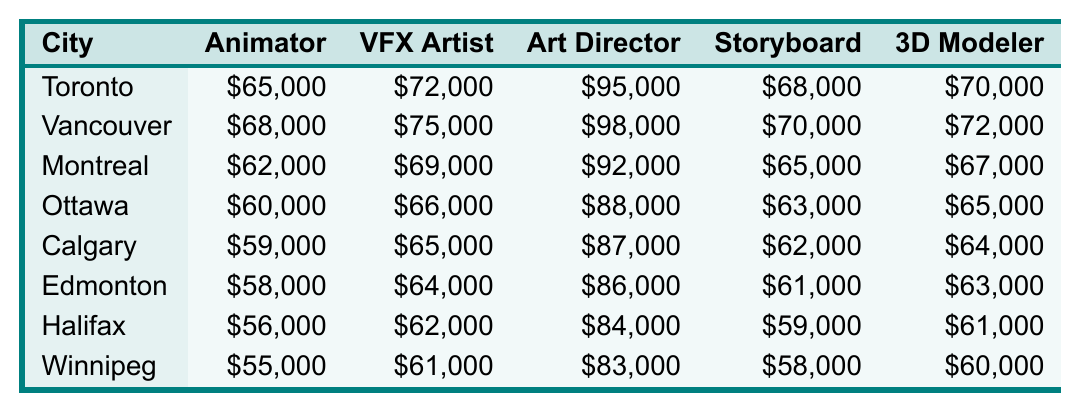What is the highest salary for an Art Director in the listed cities? The highest salary for an Art Director is in Vancouver, where it is $98,000.
Answer: $98,000 Which city offers the lowest salary for a 3D Modeler? In Winnipeg, the salary for a 3D Modeler is the lowest at $60,000.
Answer: $60,000 What is the average salary for an Animator across all the cities? Adding the salaries for Animators: 65000 + 68000 + 62000 + 60000 + 59000 + 58000 + 56000 + 55000 = 4,840,000. There are 8 cities, so the average is 4840000/8 = 60500.
Answer: $60,500 Is the salary for a Visual Effects Artist in Calgary higher than that in Ottawa? The salary for a Visual Effects Artist in Calgary is $65,000, while in Ottawa it is $66,000. Thus, it is not higher.
Answer: No Which city has the highest average salary among all roles combined? First, calculate the total salaries for each city: Toronto ($65,000 + $72,000 + $95,000 + $68,000 + $70,000 = $370,000), Vancouver ($68,000 + $75,000 + $98,000 + $70,000 + $72,000 = $383,000), Montreal ($62,000 + $69,000 + $92,000 + $65,000 + $67,000 = $355,000), Ottawa ($60,000 + $66,000 + $88,000 + $63,000 + $65,000 = $342,000), Calgary ($59,000 + $65,000 + $87,000 + $62,000 + $64,000 = $337,000), Edmonton ($58,000 + $64,000 + $86,000 + $61,000 + $63,000 = $332,000), Halifax ($56,000 + $62,000 + $84,000 + $59,000 + $61,000 = $322,000), Winnipeg ($55,000 + $61,000 + $83,000 + $58,000 + $60,000 = $317,000). The highest total is for Vancouver with $383,000, which gives an average of $383,000/5 = $76,600 for all roles in Vancouver, making it the highest average.
Answer: Vancouver Which position has the largest salary difference between Toronto and Winnipeg? The salary differences are: Animator: $65,000 - $55,000 = $10,000, Visual Effects Artist: $72,000 - $61,000 = $11,000, Art Director: $95,000 - $83,000 = $12,000, Storyboard Artist: $68,000 - $58,000 = $10,000, 3D Modeler: $70,000 - $60,000 = $10,000. The largest difference is for the Art Director position at $12,000.
Answer: Art Director Is the salary of a Storyboard Artist in Montreal more than the average salary of Storyboard Artists across all cities? The average salary for Storyboard Artists is (68000 + 70000 + 65000 + 63000 + 62000 + 61000 + 59000 + 58000) / 8 = 63,000. The salary in Montreal is $65,000, which is greater than $63,000.
Answer: Yes Which city has the highest salary for a Visual Effects Artist? Vancouver has the highest salary for a Visual Effects Artist at $75,000.
Answer: Vancouver What is the salary comparison between the Animator and the Art Director roles in Halifax? The salary for an Animator in Halifax is $56,000, while for an Art Director, it is $84,000. The Art Director role is $28,000 higher than the Animator role.
Answer: $28,000 